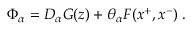Convert formula to latex. <formula><loc_0><loc_0><loc_500><loc_500>\Phi _ { \alpha } = D _ { \alpha } G ( z ) + \theta _ { \alpha } F ( x ^ { + } , x ^ { - } ) \, .</formula> 